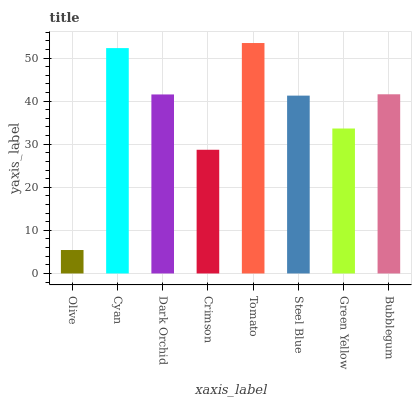Is Olive the minimum?
Answer yes or no. Yes. Is Tomato the maximum?
Answer yes or no. Yes. Is Cyan the minimum?
Answer yes or no. No. Is Cyan the maximum?
Answer yes or no. No. Is Cyan greater than Olive?
Answer yes or no. Yes. Is Olive less than Cyan?
Answer yes or no. Yes. Is Olive greater than Cyan?
Answer yes or no. No. Is Cyan less than Olive?
Answer yes or no. No. Is Dark Orchid the high median?
Answer yes or no. Yes. Is Steel Blue the low median?
Answer yes or no. Yes. Is Steel Blue the high median?
Answer yes or no. No. Is Olive the low median?
Answer yes or no. No. 